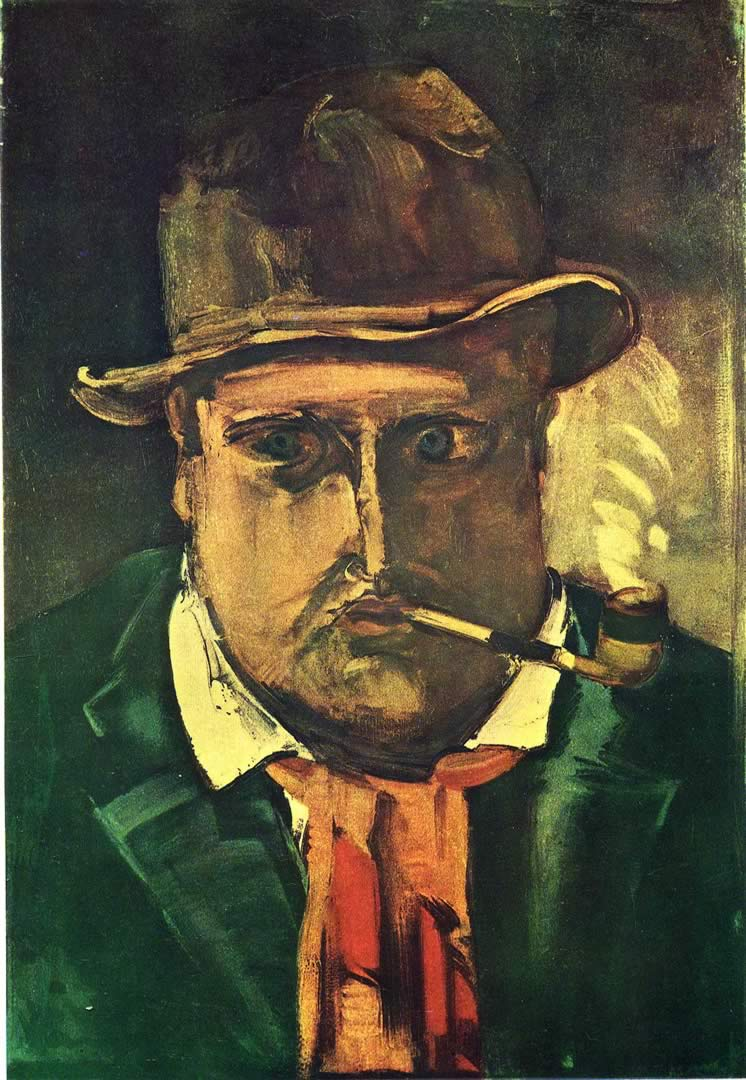Can you explain the choice of colors used in this painting? The use of dark greens and browns creates a somber and subdued backdrop, which might reflect the psychological or emotional state of the subject. In contrast, the splashes of red and yellow could symbolize moments of intensity or highlight important features, such as the pipe or the tie, drawing the viewer's attention and adding depth to the emotional landscape of the painting. How do these colors affect the mood of the viewer? The darker colors often contribute to a mood of melancholy or introspection, suitable for the expressionist goal of conveying emotional depth. The contrasting brighter colors can punctuate this mood, adding complexity and preventing the palette from becoming monotonous, thus engaging the viewer on an emotional level. 